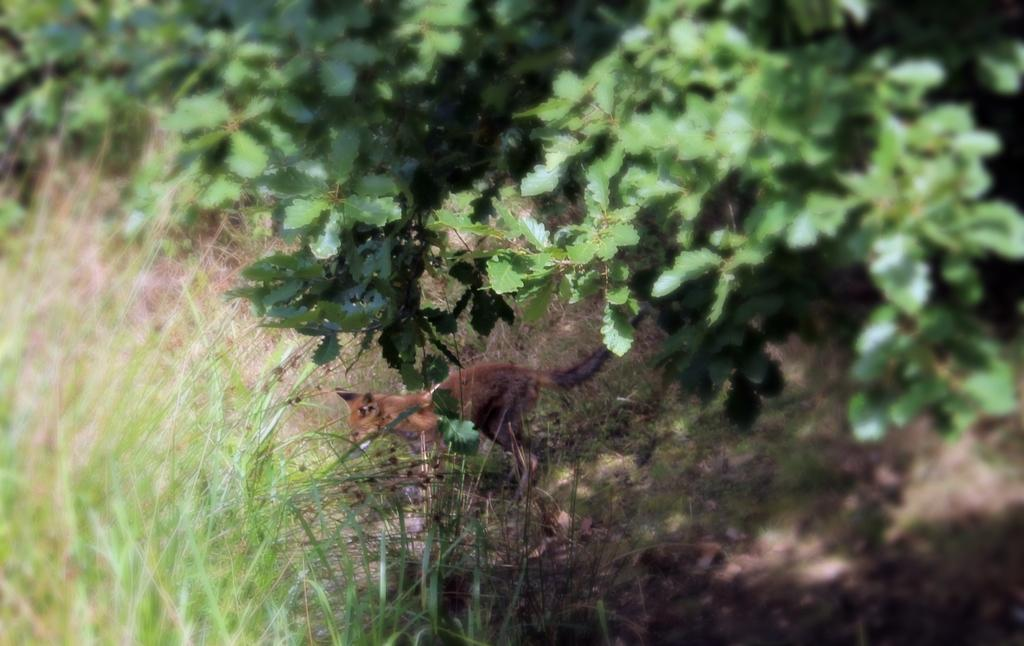What type of animal is in the image? The type of animal cannot be determined from the provided facts. Where is the animal located in the image? The animal is on the grass. What can be seen in the background of the image? Green leaves are visible in the image. What type of agreement is the animal signing in the image? There is no agreement or signing activity present in the image. What type of bone is the animal holding in the image? There is no bone present in the image. 